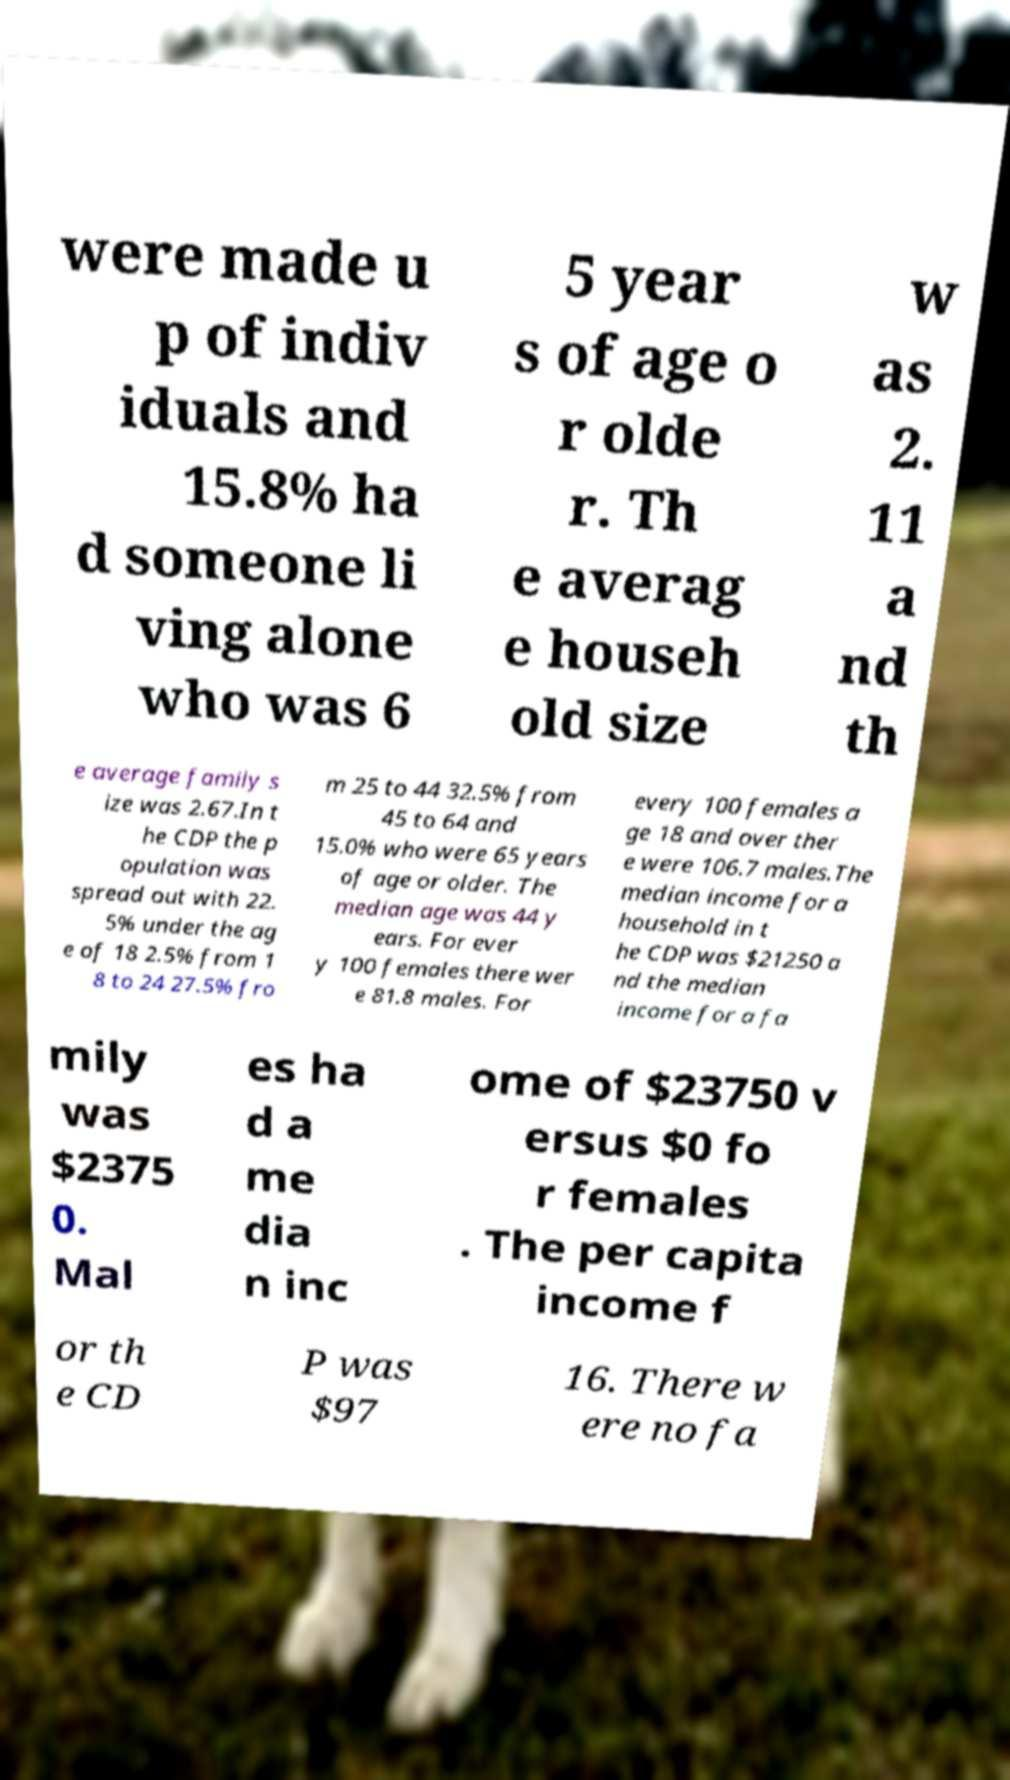What messages or text are displayed in this image? I need them in a readable, typed format. were made u p of indiv iduals and 15.8% ha d someone li ving alone who was 6 5 year s of age o r olde r. Th e averag e househ old size w as 2. 11 a nd th e average family s ize was 2.67.In t he CDP the p opulation was spread out with 22. 5% under the ag e of 18 2.5% from 1 8 to 24 27.5% fro m 25 to 44 32.5% from 45 to 64 and 15.0% who were 65 years of age or older. The median age was 44 y ears. For ever y 100 females there wer e 81.8 males. For every 100 females a ge 18 and over ther e were 106.7 males.The median income for a household in t he CDP was $21250 a nd the median income for a fa mily was $2375 0. Mal es ha d a me dia n inc ome of $23750 v ersus $0 fo r females . The per capita income f or th e CD P was $97 16. There w ere no fa 